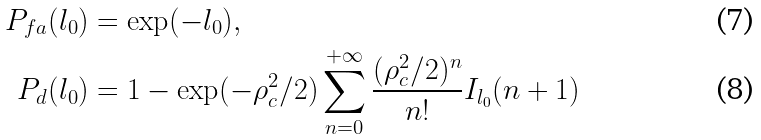<formula> <loc_0><loc_0><loc_500><loc_500>P _ { f a } ( l _ { 0 } ) & = \exp ( - l _ { 0 } ) , \\ P _ { d } ( l _ { 0 } ) & = 1 - \exp ( - \rho _ { c } ^ { 2 } / 2 ) \sum _ { n = 0 } ^ { + \infty } \frac { ( \rho _ { c } ^ { 2 } / 2 ) ^ { n } } { n ! } I _ { l _ { 0 } } ( n + 1 )</formula> 